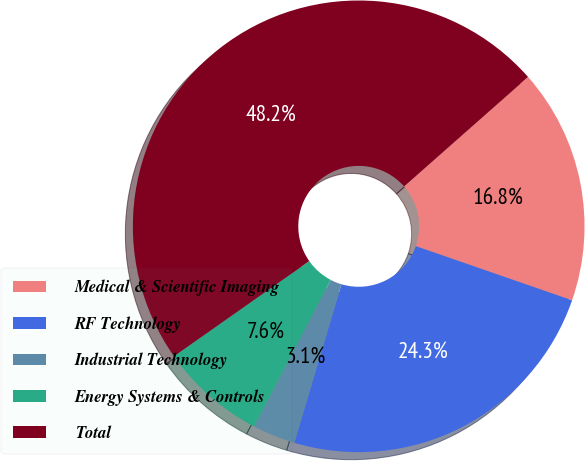Convert chart. <chart><loc_0><loc_0><loc_500><loc_500><pie_chart><fcel>Medical & Scientific Imaging<fcel>RF Technology<fcel>Industrial Technology<fcel>Energy Systems & Controls<fcel>Total<nl><fcel>16.82%<fcel>24.29%<fcel>3.06%<fcel>7.58%<fcel>48.24%<nl></chart> 